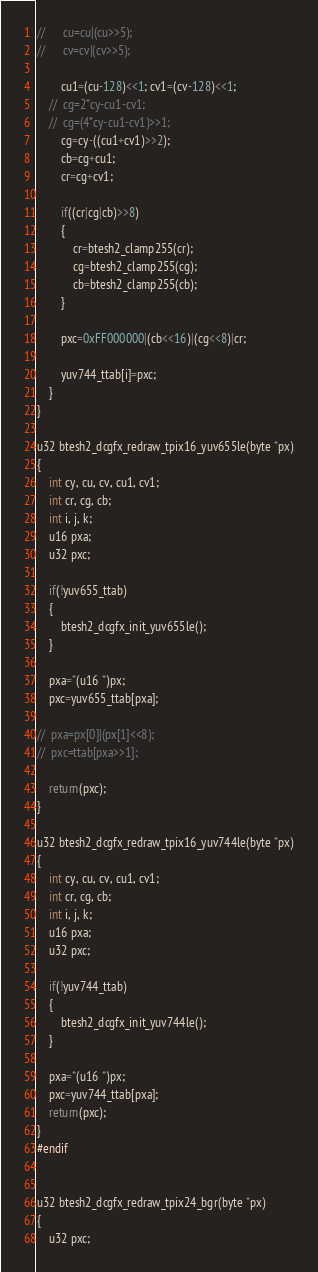<code> <loc_0><loc_0><loc_500><loc_500><_C_>//		cu=cu|(cu>>5);
//		cv=cv|(cv>>5);

		cu1=(cu-128)<<1; cv1=(cv-128)<<1;
	//	cg=2*cy-cu1-cv1;
	//	cg=(4*cy-cu1-cv1)>>1;
		cg=cy-((cu1+cv1)>>2);
		cb=cg+cu1;
		cr=cg+cv1;
		
		if((cr|cg|cb)>>8)
		{
			cr=btesh2_clamp255(cr);
			cg=btesh2_clamp255(cg);
			cb=btesh2_clamp255(cb);
		}
		
		pxc=0xFF000000|(cb<<16)|(cg<<8)|cr;
		
		yuv744_ttab[i]=pxc;
	}
}

u32 btesh2_dcgfx_redraw_tpix16_yuv655le(byte *px)
{
	int cy, cu, cv, cu1, cv1;
	int cr, cg, cb;
	int i, j, k;
	u16 pxa;
	u32 pxc;
	
	if(!yuv655_ttab)
	{
		btesh2_dcgfx_init_yuv655le();
	}

	pxa=*(u16 *)px;
	pxc=yuv655_ttab[pxa];
	
//	pxa=px[0]|(px[1]<<8);
//	pxc=ttab[pxa>>1];

	return(pxc);
}

u32 btesh2_dcgfx_redraw_tpix16_yuv744le(byte *px)
{
	int cy, cu, cv, cu1, cv1;
	int cr, cg, cb;
	int i, j, k;
	u16 pxa;
	u32 pxc;
	
	if(!yuv744_ttab)
	{
		btesh2_dcgfx_init_yuv744le();
	}

	pxa=*(u16 *)px;
	pxc=yuv744_ttab[pxa];
	return(pxc);
}
#endif


u32 btesh2_dcgfx_redraw_tpix24_bgr(byte *px)
{
	u32 pxc;</code> 